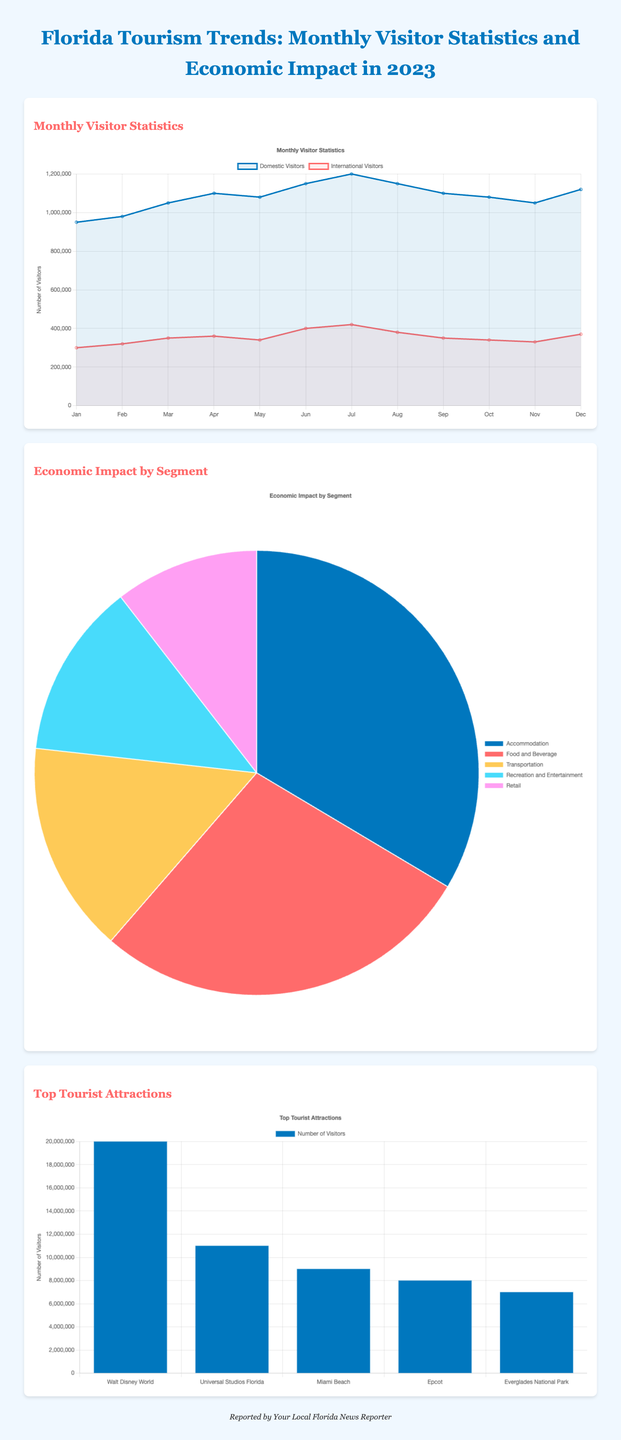what is the total number of domestic visitors in July? The total number of domestic visitors in July is specifically indicated in the chart as 1200000.
Answer: 1200000 which month had the highest number of international visitors? The month indicated for the highest number of international visitors is July, with a total of 420000 visitors.
Answer: July what is the economic impact of the Food and Beverage segment? The economic impact of the Food and Beverage segment is shown to be 8500000000.
Answer: 8500000000 how many visitors does Walt Disney World attract? The chart states that Walt Disney World attracts 20000000 visitors.
Answer: 20000000 what is the total economic impact represented in the chart? The total economic impact can be understood by adding all segments: Accommodation, Food and Beverage, Transportation, Recreation and Entertainment, and Retail, resulting in a total of 34000000000.
Answer: 34000000000 which tourist attraction has the second highest number of visitors? The tourist attraction with the second highest number of visitors is Universal Studios Florida, with 11000000 visitors.
Answer: Universal Studios Florida how many tourist attractions are listed in the document? The document lists a total of five tourist attractions in its section.
Answer: Five what percentage of the economic impact does Transportation represent? The economic impact of Transportation is primarily noted as 4700000000, which requires calculation in relation to total economic impact for percentage representation, yielding approximately 13.82%.
Answer: 13.82% which month shows a decrease in domestic visitors compared to the previous month? A decrease in domestic visitors is observed from June to July, as the number dropped from 1150000 to 1200000.
Answer: None 